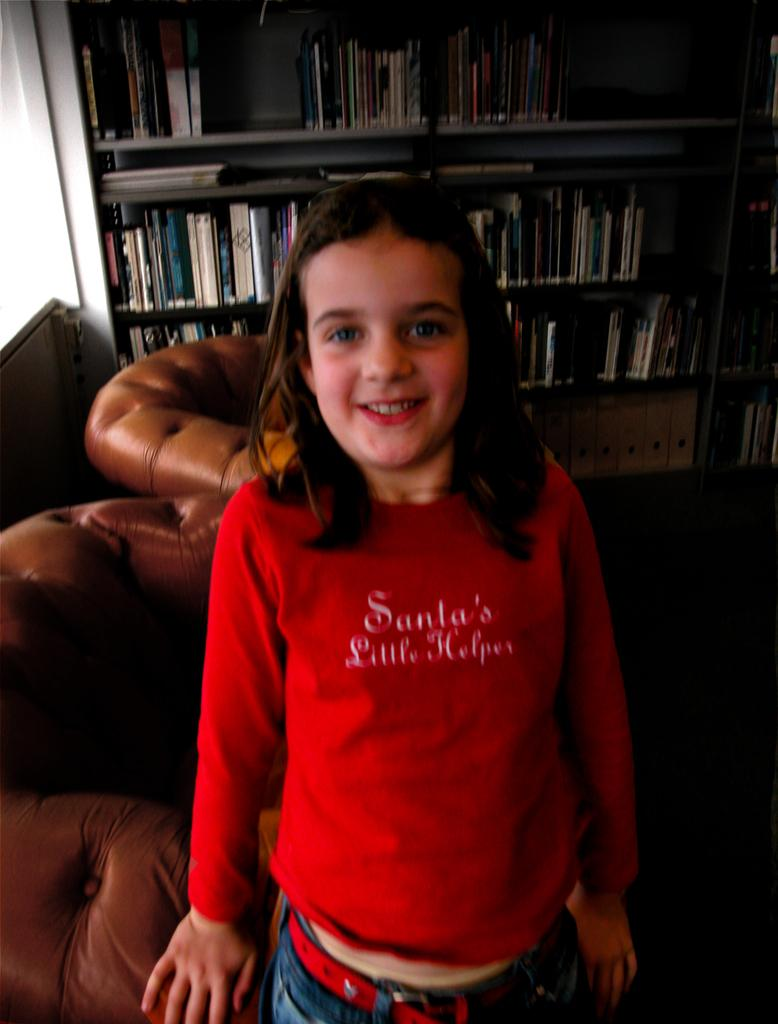Provide a one-sentence caption for the provided image. A girl wearing a red Santa's Little Helper shirt standing in front of a bookcase. 